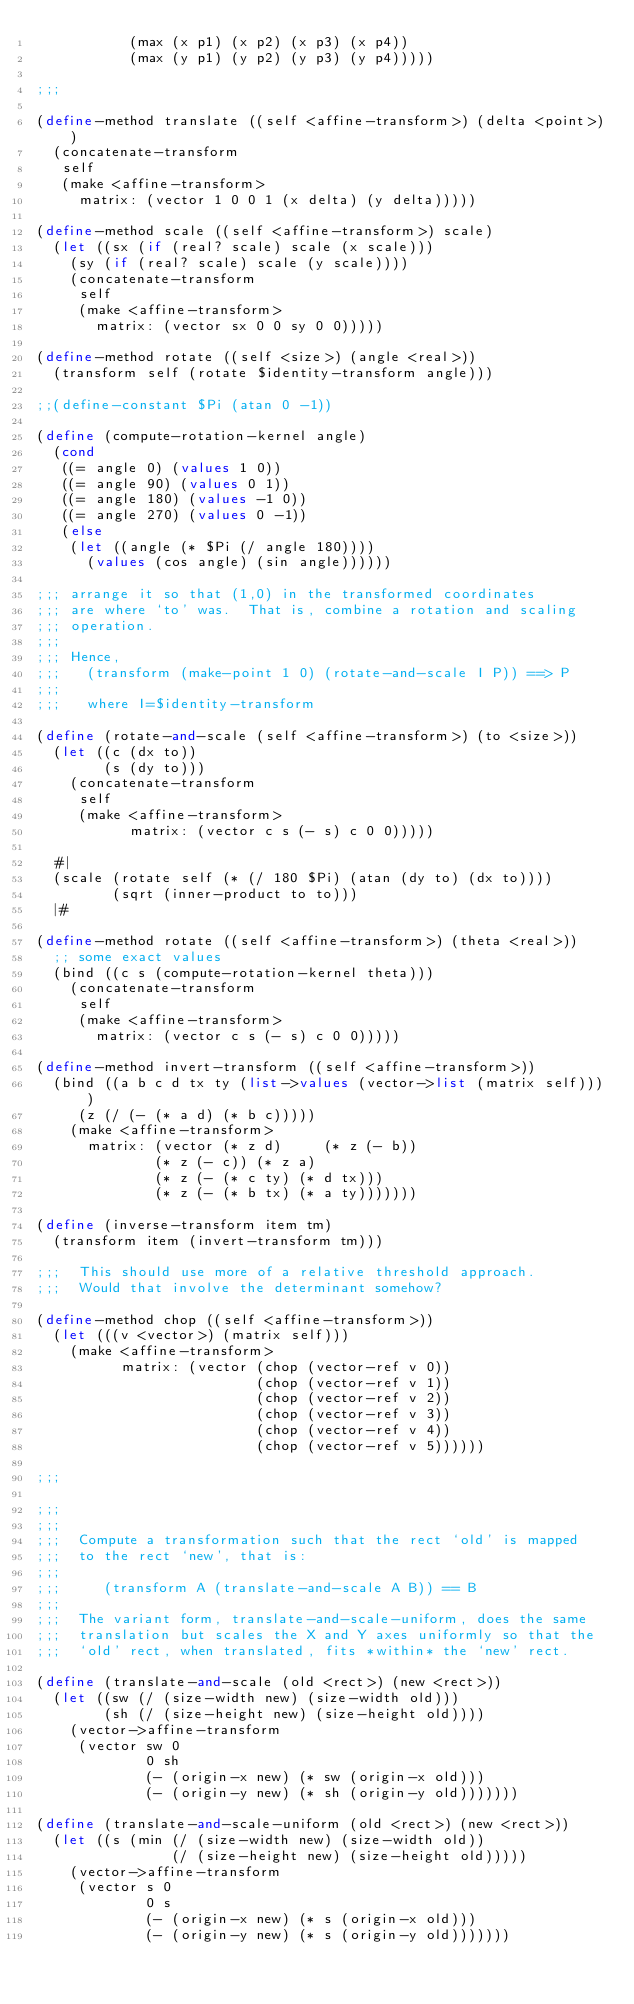<code> <loc_0><loc_0><loc_500><loc_500><_Scheme_>	       (max (x p1) (x p2) (x p3) (x p4))
	       (max (y p1) (y p2) (y p3) (y p4)))))

;;;

(define-method translate ((self <affine-transform>) (delta <point>))
  (concatenate-transform 
   self
   (make <affine-transform>
	 matrix: (vector 1 0 0 1 (x delta) (y delta)))))

(define-method scale ((self <affine-transform>) scale)
  (let ((sx (if (real? scale) scale (x scale)))
	(sy (if (real? scale) scale (y scale))))
    (concatenate-transform
     self
     (make <affine-transform>
	   matrix: (vector sx 0 0 sy 0 0)))))

(define-method rotate ((self <size>) (angle <real>))
  (transform self (rotate $identity-transform angle)))

;;(define-constant $Pi (atan 0 -1))

(define (compute-rotation-kernel angle)
  (cond
   ((= angle 0) (values 1 0))
   ((= angle 90) (values 0 1))
   ((= angle 180) (values -1 0))
   ((= angle 270) (values 0 -1))
   (else
    (let ((angle (* $Pi (/ angle 180))))
      (values (cos angle) (sin angle))))))

;;; arrange it so that (1,0) in the transformed coordinates
;;; are where `to' was.  That is, combine a rotation and scaling
;;; operation.
;;;
;;; Hence,
;;;   (transform (make-point 1 0) (rotate-and-scale I P)) ==> P
;;;
;;;   where I=$identity-transform

(define (rotate-and-scale (self <affine-transform>) (to <size>))
  (let ((c (dx to))
        (s (dy to)))
    (concatenate-transform 
     self
     (make <affine-transform>
           matrix: (vector c s (- s) c 0 0)))))

  #|
  (scale (rotate self (* (/ 180 $Pi) (atan (dy to) (dx to))))
         (sqrt (inner-product to to)))
  |#

(define-method rotate ((self <affine-transform>) (theta <real>))
  ;; some exact values
  (bind ((c s (compute-rotation-kernel theta)))
    (concatenate-transform 
     self
     (make <affine-transform>
       matrix: (vector c s (- s) c 0 0)))))

(define-method invert-transform ((self <affine-transform>))
  (bind ((a b c d tx ty (list->values (vector->list (matrix self))))
	 (z (/ (- (* a d) (* b c)))))
    (make <affine-transform>
	  matrix: (vector (* z d)     (* z (- b))
			  (* z (- c)) (* z a)
			  (* z (- (* c ty) (* d tx)))  
			  (* z (- (* b tx) (* a ty)))))))

(define (inverse-transform item tm)
  (transform item (invert-transform tm)))

;;;  This should use more of a relative threshold approach.
;;;  Would that involve the determinant somehow?

(define-method chop ((self <affine-transform>))
  (let (((v <vector>) (matrix self)))
    (make <affine-transform>
          matrix: (vector (chop (vector-ref v 0))
                          (chop (vector-ref v 1))
                          (chop (vector-ref v 2))
                          (chop (vector-ref v 3))
                          (chop (vector-ref v 4))
                          (chop (vector-ref v 5))))))

;;;

;;;
;;;
;;;  Compute a transformation such that the rect `old' is mapped
;;;  to the rect `new', that is:
;;;
;;;     (transform A (translate-and-scale A B)) == B
;;;
;;;  The variant form, translate-and-scale-uniform, does the same
;;;  translation but scales the X and Y axes uniformly so that the
;;;  `old' rect, when translated, fits *within* the `new' rect.

(define (translate-and-scale (old <rect>) (new <rect>))
  (let ((sw (/ (size-width new) (size-width old)))
        (sh (/ (size-height new) (size-height old))))
    (vector->affine-transform
     (vector sw 0
             0 sh
             (- (origin-x new) (* sw (origin-x old)))
             (- (origin-y new) (* sh (origin-y old)))))))

(define (translate-and-scale-uniform (old <rect>) (new <rect>))
  (let ((s (min (/ (size-width new) (size-width old))
                (/ (size-height new) (size-height old)))))
    (vector->affine-transform
     (vector s 0
             0 s
             (- (origin-x new) (* s (origin-x old)))
             (- (origin-y new) (* s (origin-y old)))))))


</code> 